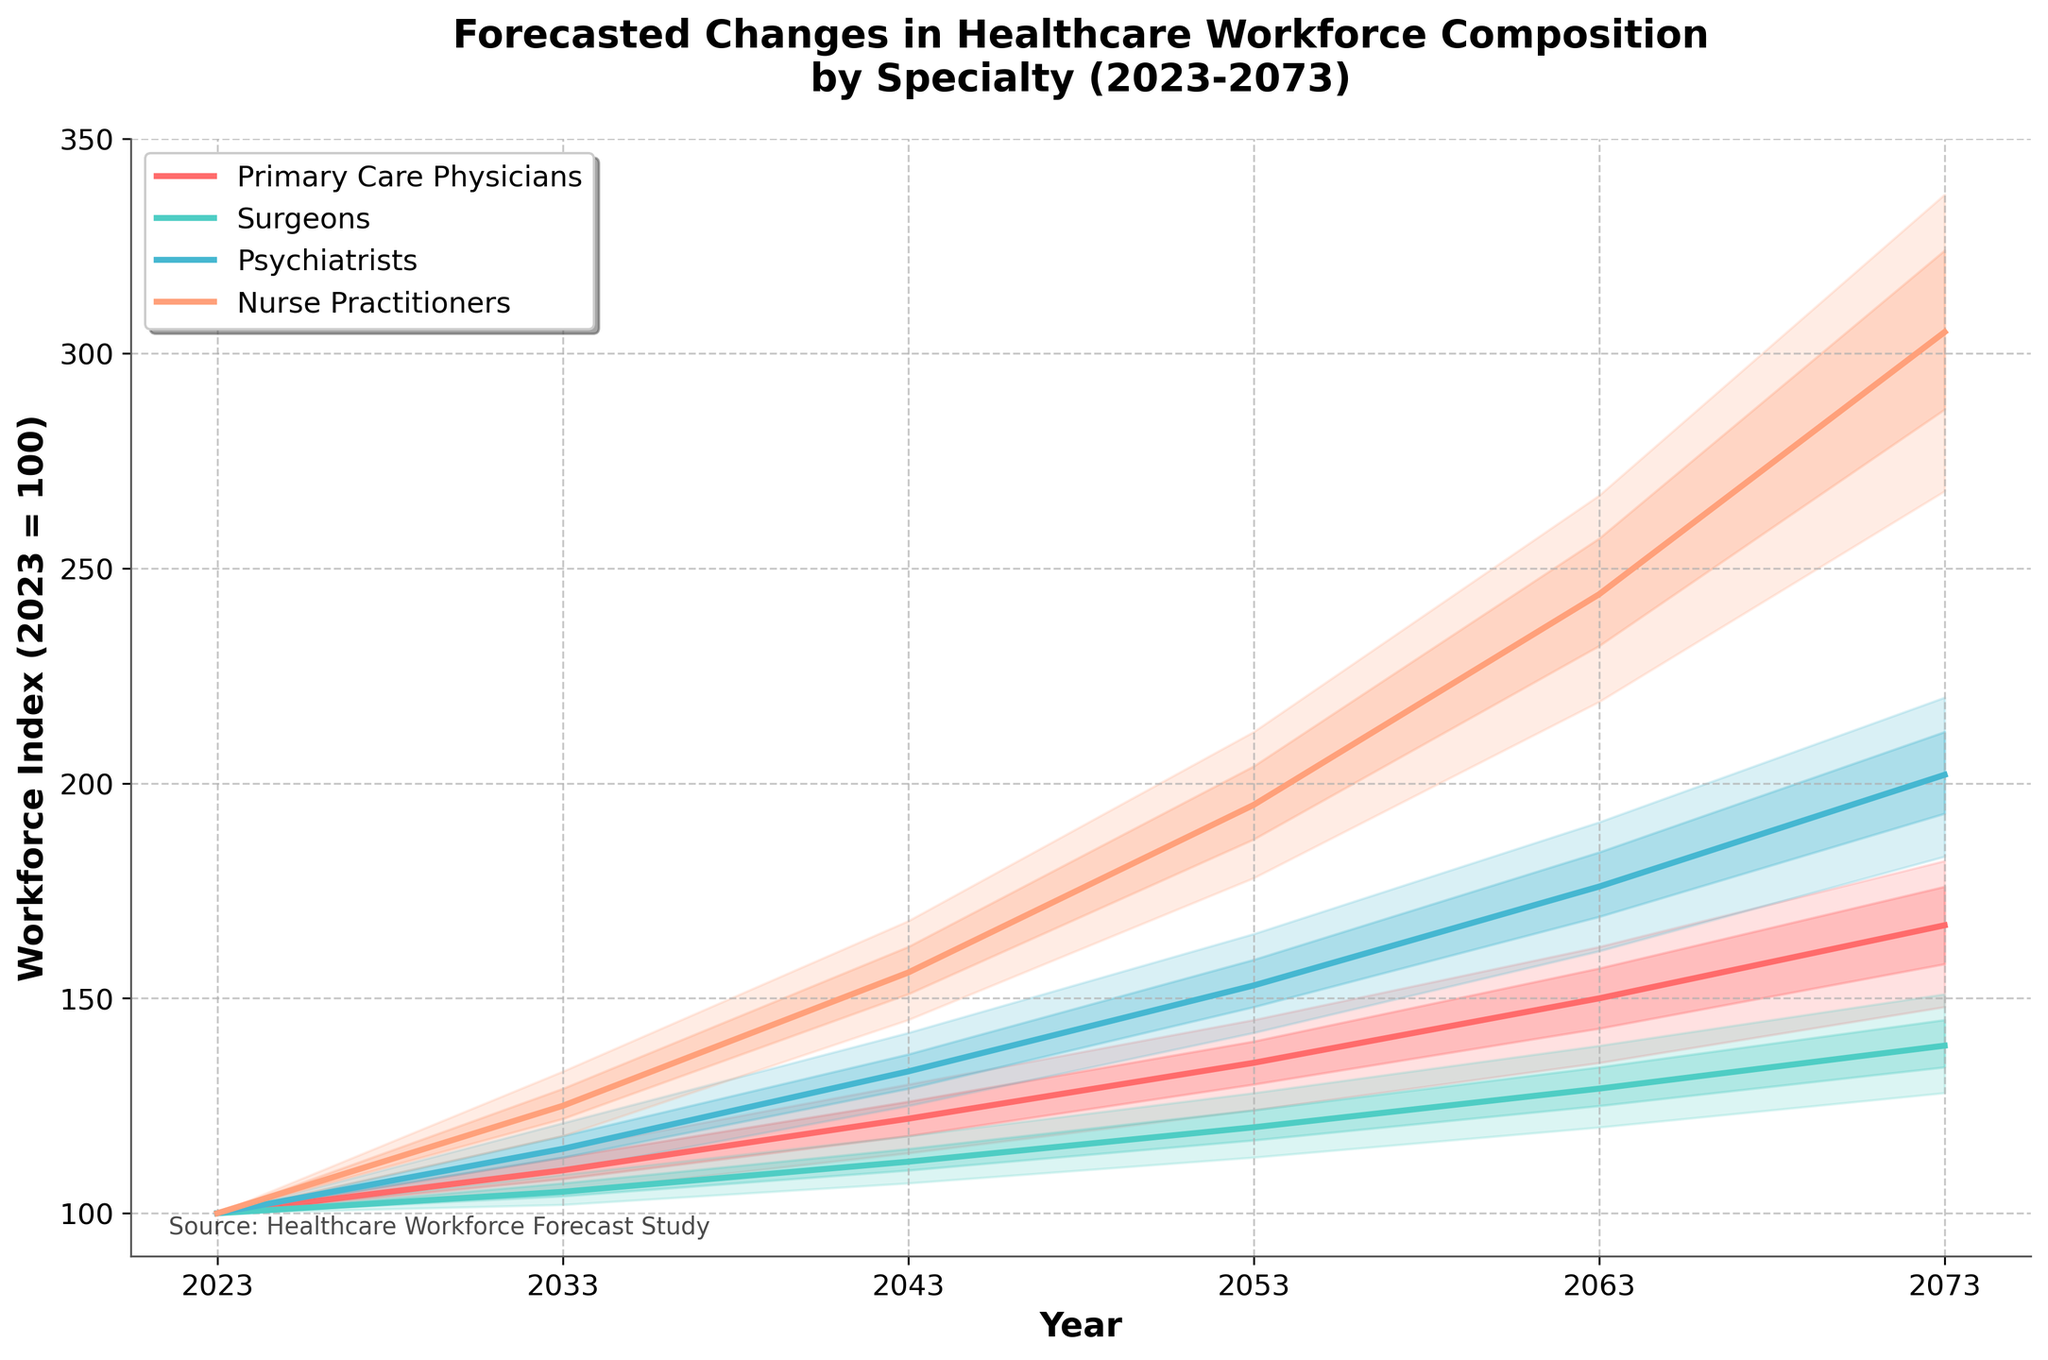What is the title of the plot? The title of the plot is prominently displayed at the top of the figure, reading "Forecasted Changes in Healthcare Workforce Composition by Specialty (2023-2073)."
Answer: Forecasted Changes in Healthcare Workforce Composition by Specialty (2023-2073) What are the colors associated with each specialty line? Across the chart, we see various colors: Primary Care Physicians use a red color, Surgeons use a teal color, Psychiatrists use a darker blue color, and Nurse Practitioners use a peach color.
Answer: Primary Care Physicians (red), Surgeons (teal), Psychiatrists (dark blue), Nurse Practitioners (peach) Which specialty has the highest median forecast in 2073? We look for the median values plotted in 2073 and see Nurse Practitioners have the highest value of 305 among all specialties.
Answer: Nurse Practitioners What is the range of the lower 25th percentile to the upper 75th percentile for Primary Care Physicians in 2063? Analyze the shaded areas in 2063: the Primary Care Physicians' lower 25th percentile is 143 and the upper 75th percentile is 157, giving a range of 157 - 143 = 14.
Answer: 14 By how much does the median forecast for Psychiatrists increase from 2023 to 2073? The median value for Psychiatrists in 2023 is 100, and in 2073 it is 202. By calculating the difference, we get 202 - 100 = 102.
Answer: 102 Between which years does the largest increase in the median forecast for Nurse Practitioners occur? Examine the median values for Nurse Practitioners: The largest increase occurs between 2063 (244) and 2073 (305), which is 305 - 244 = 61.
Answer: 2063 and 2073 Which specialty shows the smallest growth in workforce index from 2023 to 2073? Compare the forecasted growth of each specialty: It appears Surgeons have the smallest growth, going from 100 in 2023 to 139 in 2073, which is an increase of 39.
Answer: Surgeons What is the median forecast for Surgeons in 2053? Look at the median value plotted for Surgeons in 2053, which is 120.
Answer: 120 How does the upper 90th percentile forecast for Nurse Practitioners in 2073 compare to the median forecast for Primary Care Physicians in 2073? For the year 2073, the upper 90th percentile for Nurse Practitioners is 337, while the median forecast for Primary Care Physicians is 167. Comparing these, 337 is significantly higher than 167.
Answer: Higher Between which two specialties does the rate of increase in median workforce index appear most divergent over time? Comparing across the time series: Psychiatrists and Nurse Practitioners show much larger increases in their indices compared to Primary Care Physicians and Surgeons, making them the most divergent in terms of increasing rates.
Answer: Psychiatrists and Nurse Practitioners 